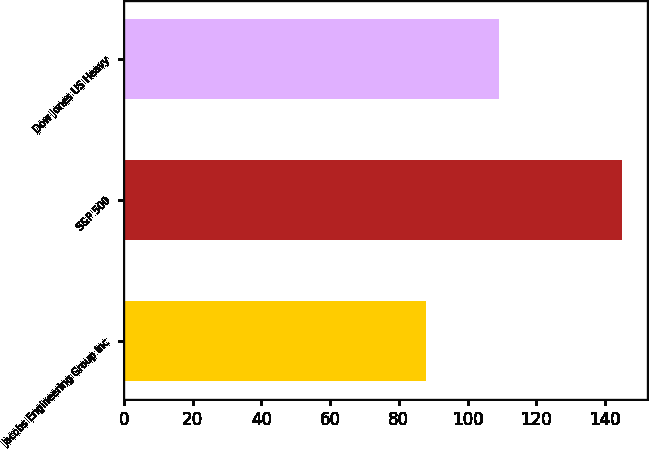Convert chart to OTSL. <chart><loc_0><loc_0><loc_500><loc_500><bar_chart><fcel>Jacobs Engineering Group Inc<fcel>S&P 500<fcel>Dow Jones US Heavy<nl><fcel>87.99<fcel>145.07<fcel>109.07<nl></chart> 